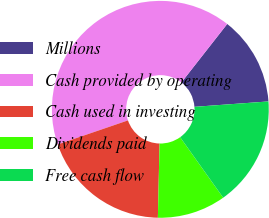Convert chart to OTSL. <chart><loc_0><loc_0><loc_500><loc_500><pie_chart><fcel>Millions<fcel>Cash provided by operating<fcel>Cash used in investing<fcel>Dividends paid<fcel>Free cash flow<nl><fcel>13.26%<fcel>40.83%<fcel>19.39%<fcel>10.2%<fcel>16.32%<nl></chart> 